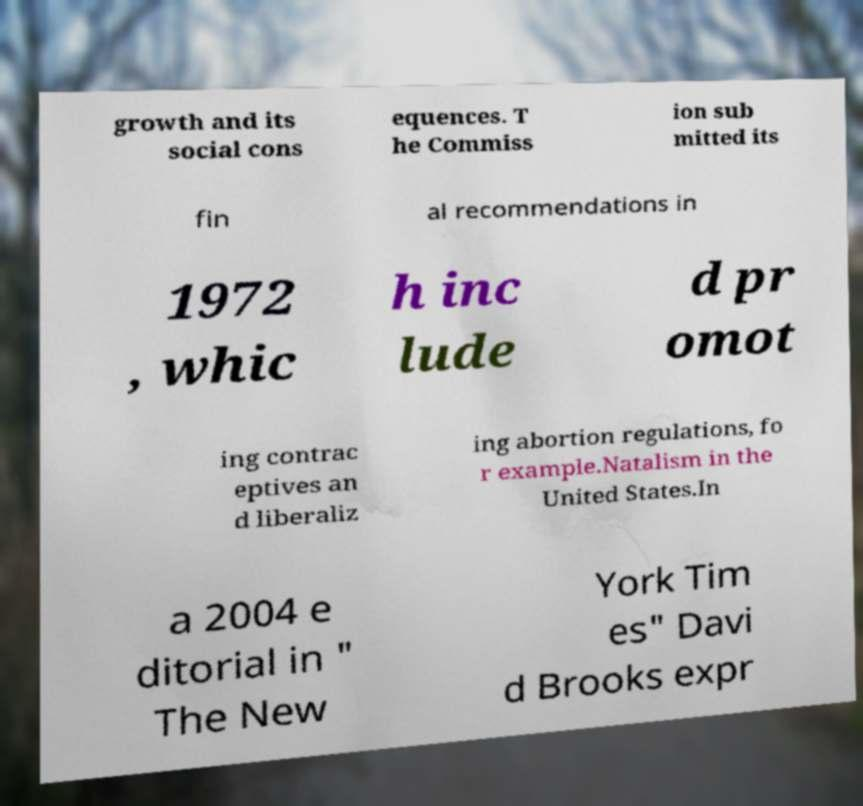Could you assist in decoding the text presented in this image and type it out clearly? growth and its social cons equences. T he Commiss ion sub mitted its fin al recommendations in 1972 , whic h inc lude d pr omot ing contrac eptives an d liberaliz ing abortion regulations, fo r example.Natalism in the United States.In a 2004 e ditorial in " The New York Tim es" Davi d Brooks expr 